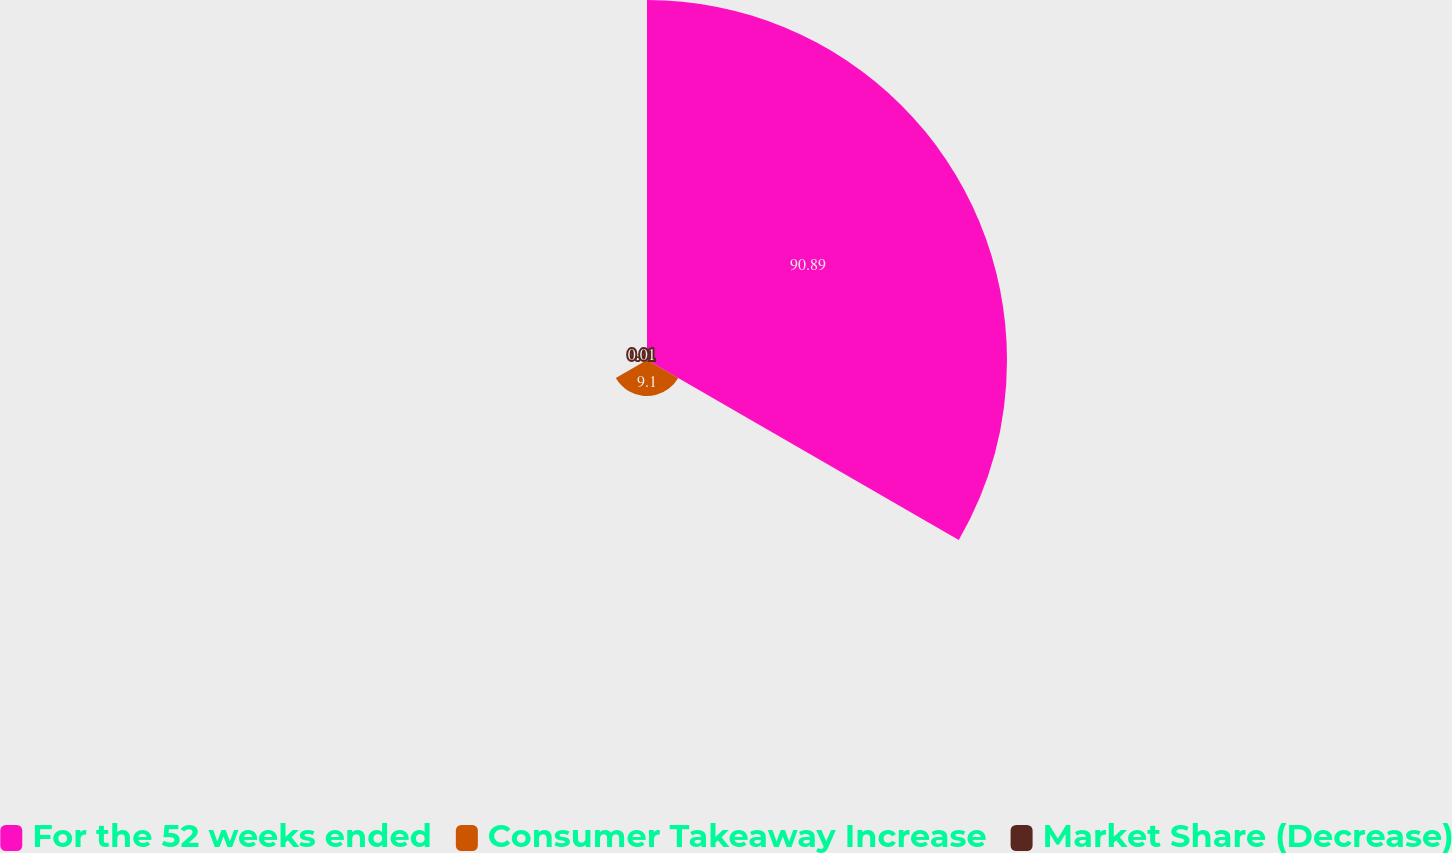<chart> <loc_0><loc_0><loc_500><loc_500><pie_chart><fcel>For the 52 weeks ended<fcel>Consumer Takeaway Increase<fcel>Market Share (Decrease)<nl><fcel>90.89%<fcel>9.1%<fcel>0.01%<nl></chart> 